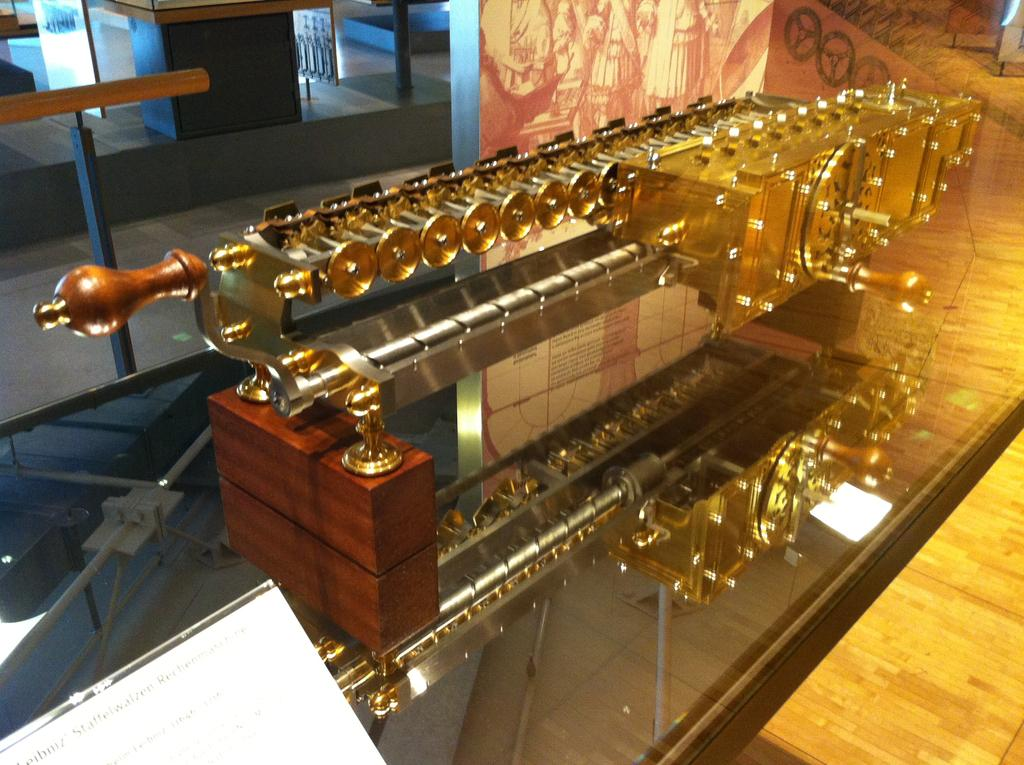What is the main subject in the image? There is a machine in the image. What other object can be seen in the image? There is a wooden object in the image. How many snails can be seen crawling on the machine in the image? There are no snails present in the image. What is the moon's position in the image? The moon is not visible in the image. Can you tell me how many people are operating the machine in the image? There is no person present in the image. 